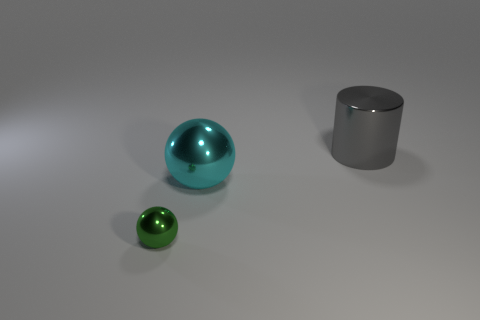Are there fewer large gray shiny objects that are in front of the large cyan ball than large cyan shiny objects behind the big cylinder?
Your response must be concise. No. Is there anything else that has the same shape as the cyan thing?
Offer a terse response. Yes. There is a large object that is on the left side of the big metal cylinder; what is it made of?
Offer a terse response. Metal. Are there the same number of blue shiny things and small things?
Provide a succinct answer. No. Is there anything else that is the same size as the gray cylinder?
Your answer should be compact. Yes. Are there any balls to the left of the small metallic object?
Keep it short and to the point. No. What is the shape of the large cyan object?
Your answer should be compact. Sphere. How many objects are either objects behind the small thing or cyan metallic things?
Ensure brevity in your answer.  2. What number of other objects are there of the same color as the tiny ball?
Make the answer very short. 0. There is a large shiny cylinder; is it the same color as the metal ball behind the small ball?
Keep it short and to the point. No. 